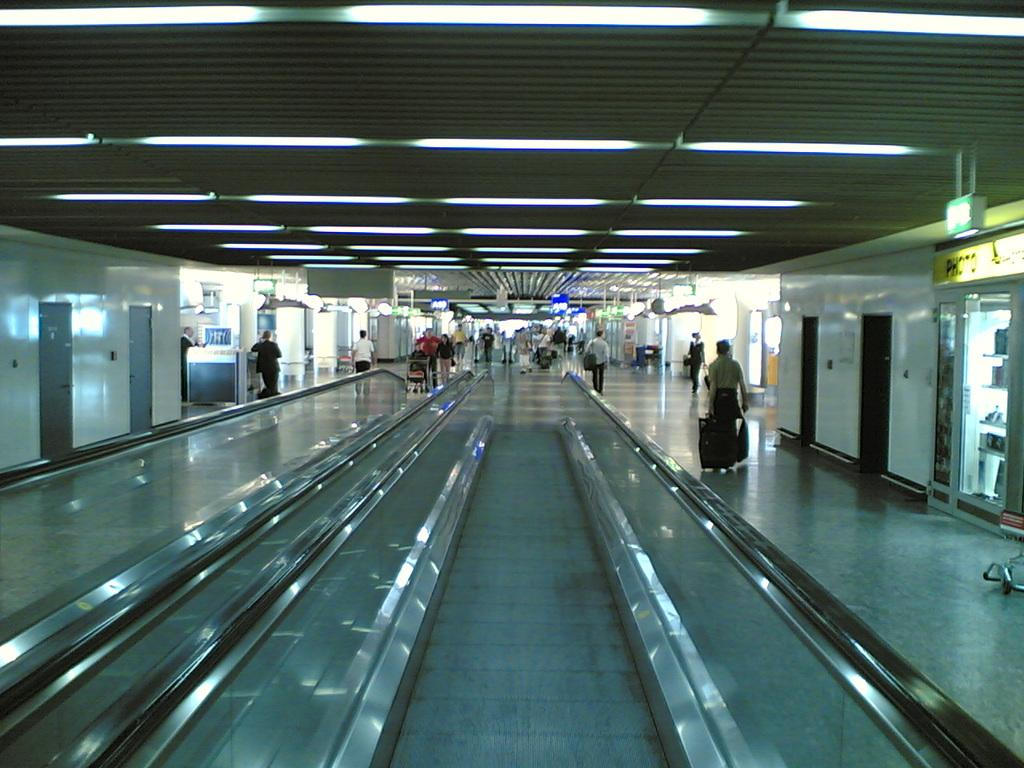What is the main subject in the foreground of the image? There is a subway in the foreground of the image. Can you describe the people in the image? There are people in the image. What can be seen in the background of the image? There are posters, doors, and light visible in the background of the image. Can you tell me how many snails are crawling on the edge of the subway in the image? There are no snails present in the image, and therefore no such activity can be observed. 